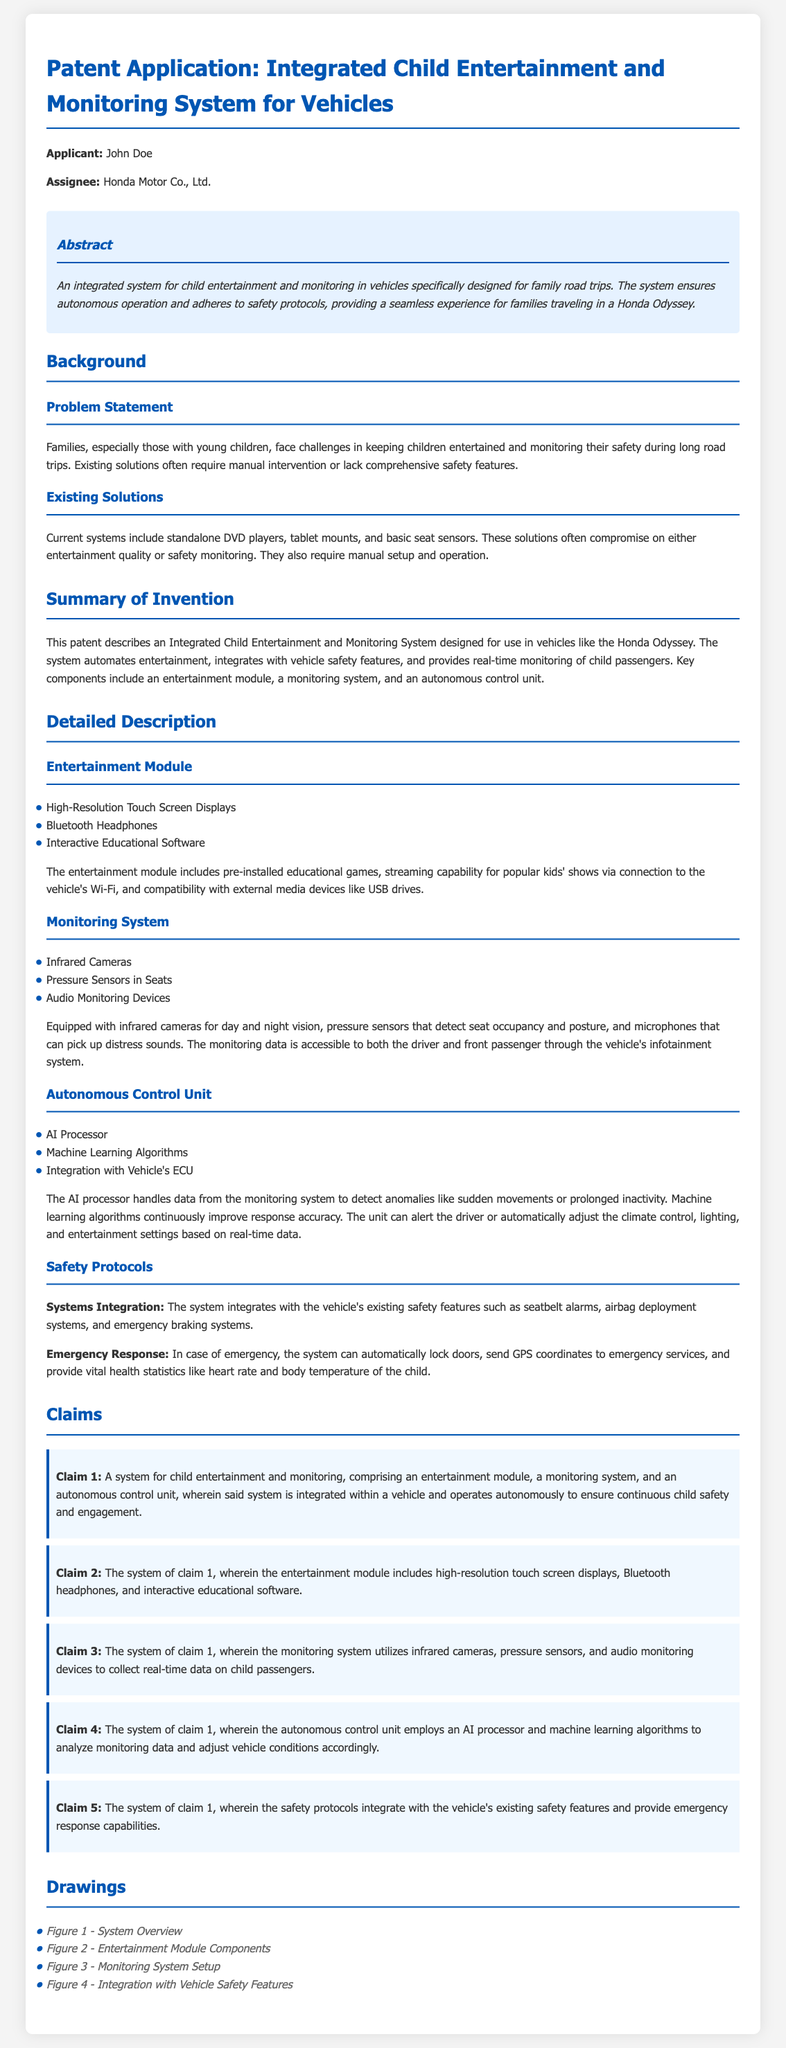What is the name of the applicant? The applicant's name is stated in the document's section for applicant information.
Answer: John Doe Who is the assignee of the patent? The assignee is mentioned in the introductory section of the document.
Answer: Honda Motor Co., Ltd What are the three key components of the system? The summary section lists the main components of the system.
Answer: Entertainment module, monitoring system, autonomous control unit What type of sensors are included in the monitoring system? The detailed description outlines the types of devices used for monitoring child passengers.
Answer: Infrared cameras, pressure sensors, audio monitoring devices How does the autonomous control unit respond to detected anomalies? The detailed description explains the functions of the autonomous control unit when it detects anomalies.
Answer: Alerts the driver or automatically adjusts settings What emergency response capabilities does the system provide? The safety protocols section discusses the emergency responses facilitated by the system.
Answer: Lock doors, send GPS coordinates, provide health statistics What additional features does the entertainment module provide? The description of the entertainment module highlights some of its features.
Answer: High-Resolution Touch Screen Displays What is the purpose of the AI processor in the system? The detailed description explains the role of the AI processor in managing data.
Answer: Handle data from the monitoring system How many claims are included in the patent application? The claims section explicitly enumerates the claims made in the patent.
Answer: Five 